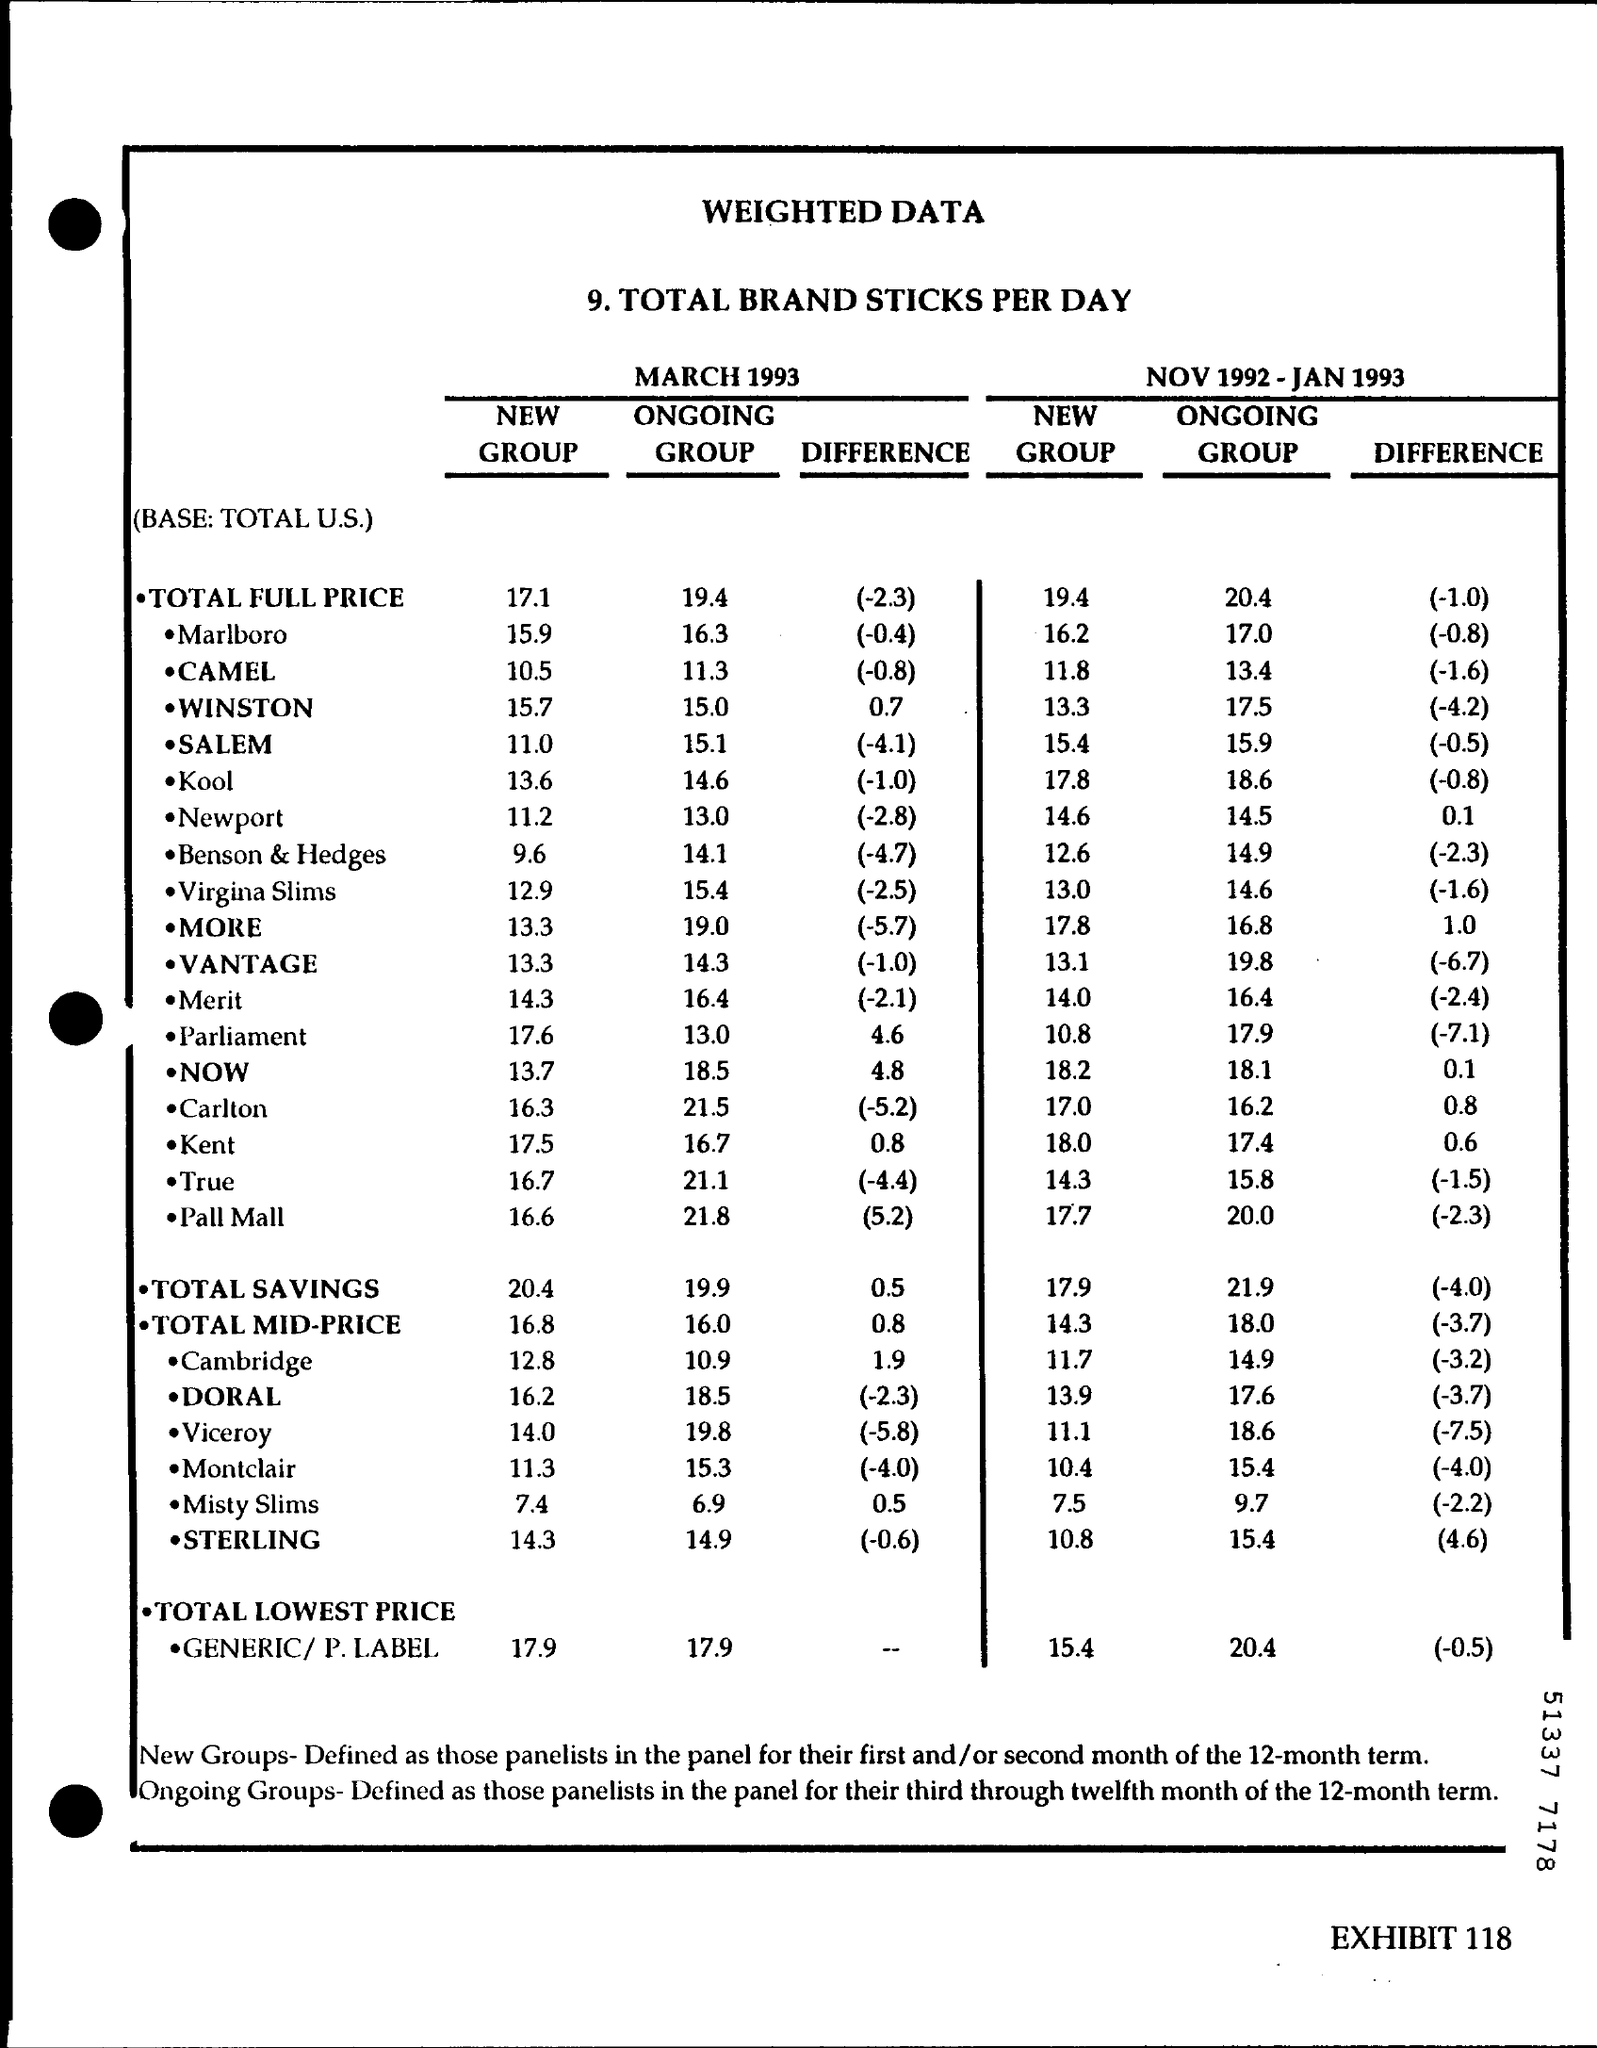What is the Total Savings for New group for March 1993?
Make the answer very short. 20.4. What is the Total Savings for Ongoing group for March 1993?
Your response must be concise. 19.9. What is the Total Savings for Ongoing group for NOV 1992-JAN 1993?
Offer a terse response. 21.9. What is the Total Savings for New group for NOV 1992-JAN 1993?
Your answer should be compact. 17.9. What is the Total Mid-Price for Ongoing group for NOV 1992-JAN 1993?
Make the answer very short. 18.0. What is the Total Mid-Price for New group for NOV 1992-JAN 1993?
Make the answer very short. 14.3. 